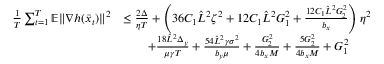Convert formula to latex. <formula><loc_0><loc_0><loc_500><loc_500>\begin{array} { r l } { \frac { 1 } { T } \sum _ { t = 1 } ^ { T } \mathbb { E } \| \nabla h ( \bar { x } _ { t } ) \| ^ { 2 } } & { \leq \frac { 2 \Delta } { \eta T } + \left ( 3 6 C _ { 1 } \hat { L } ^ { 2 } \zeta ^ { 2 } + 1 2 C _ { 1 } \hat { L } ^ { 2 } G _ { 1 } ^ { 2 } + \frac { 1 2 C _ { 1 } \hat { L } ^ { 2 } G _ { 2 } ^ { 2 } } { b _ { x } } \right ) \eta ^ { 2 } } \\ & { \quad + \frac { 1 8 \hat { L } ^ { 2 } \Delta _ { y } } { \mu \gamma T } + \frac { 5 4 \hat { L } ^ { 2 } \gamma \sigma ^ { 2 } } { b _ { y } \mu } + \frac { G _ { 2 } ^ { 2 } } { 4 b _ { x } M } + \frac { 5 G _ { 2 } ^ { 2 } } { 4 b _ { x } M } + G _ { 1 } ^ { 2 } } \end{array}</formula> 